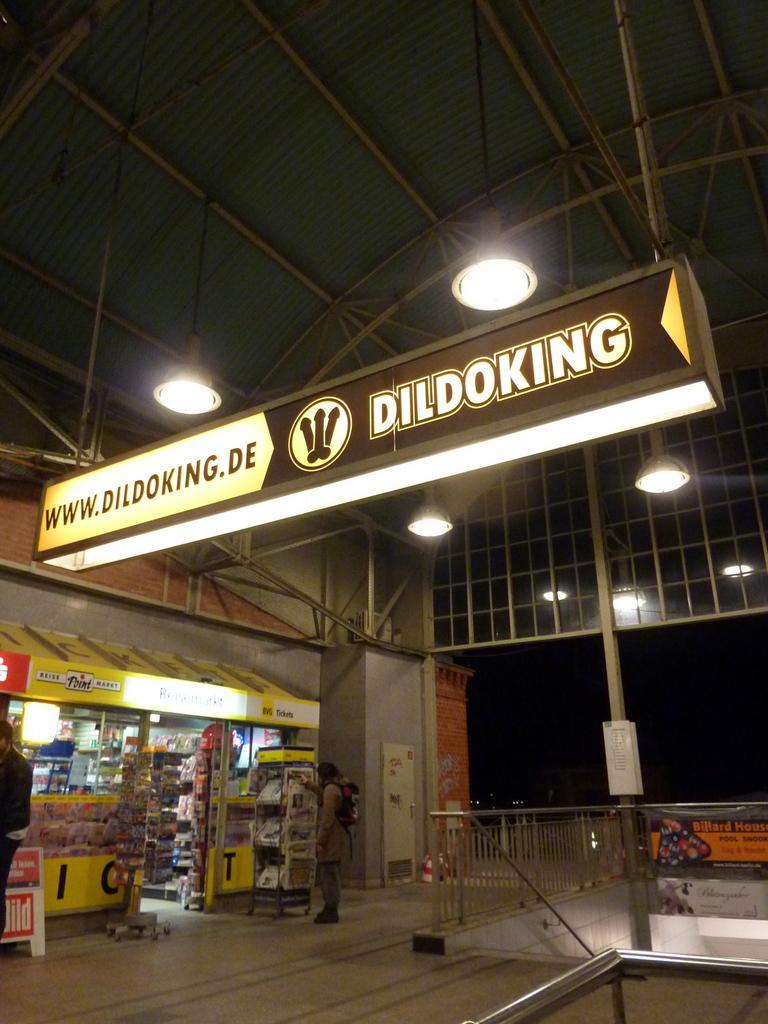Describe this image in one or two sentences. On the left side there is a stall. There are many items in the stall. Something is written on the stall. Also there is a poster in front of that. A person wearing cap and bag is standing in front of that. On the right side there is a railing and pillar. On the ceiling there are lights. And a name board with light is hanged from the ceiling. 